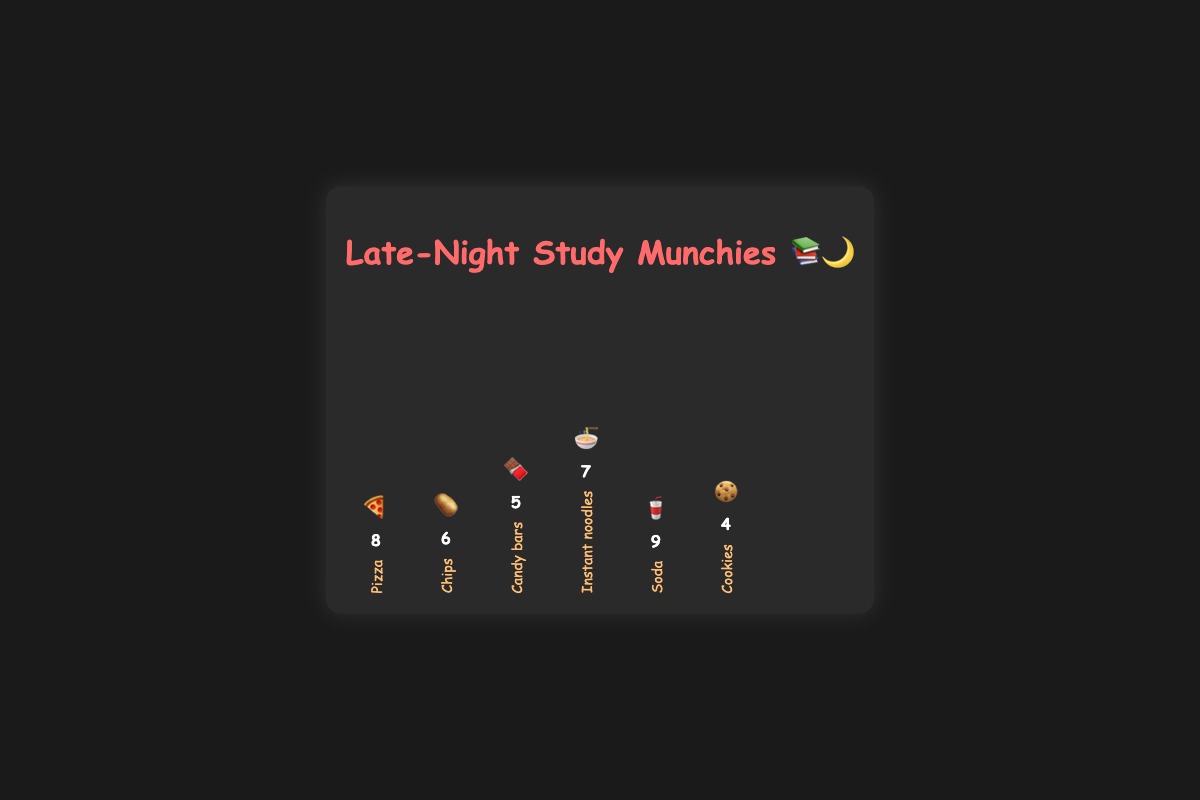What is the most consumed type of junk food during late-night study sessions? The chart shows "Soda" 🥤 with the highest bar, indicating it is consumed the most
Answer: Soda Which food item has the fewest count, and how many times was it consumed? The bar for "Cookies" 🍪 is the shortest, and the count is shown as 4 times
Answer: Cookies, 4 times How many more times was Soda 🥤 consumed compared to Candy bars 🍫? Soda was consumed 9 times and Candy bars 5 times, the difference is 9 - 5 = 4
Answer: 4 times Calculate the total count of all food items combined Adding up all counts: 8 (Pizza) + 6 (Chips) + 5 (Candy bars) + 7 (Instant noodles) + 9 (Soda) + 4 (Cookies) = 39
Answer: 39 Which two food items have a combined consumption count of 14? Instant noodles (7) + Chips (6) = 13, not a match; Pizza (8) + Candy bars (5) = 13, not a match; Soda (9) + Cookies (4) = 13, not a match; therefore, no match found, but individually, Instant noodles (7) + Candy bars (5) + Cookies (4) = 16; thus only partial data available.
Answer: None What is the median count of the food items? The list of counts in ascending order: 4, 5, 6, 7, 8, 9. The median is the average of the middle two values (6 and 7), so (6 + 7) / 2 = 6.5
Answer: 6.5 Which two types of junk food were consumed equally? Checking the bars, there are no two bars exactly equal in this plot.
Answer: None If looking at the bars representing Instant noodles 🍜 and Chips 🥔, how many more times was Instant noodles consumed? Instant noodles were consumed 7 times and Chips 6 times, the difference is 7 - 6 = 1
Answer: 1 time 